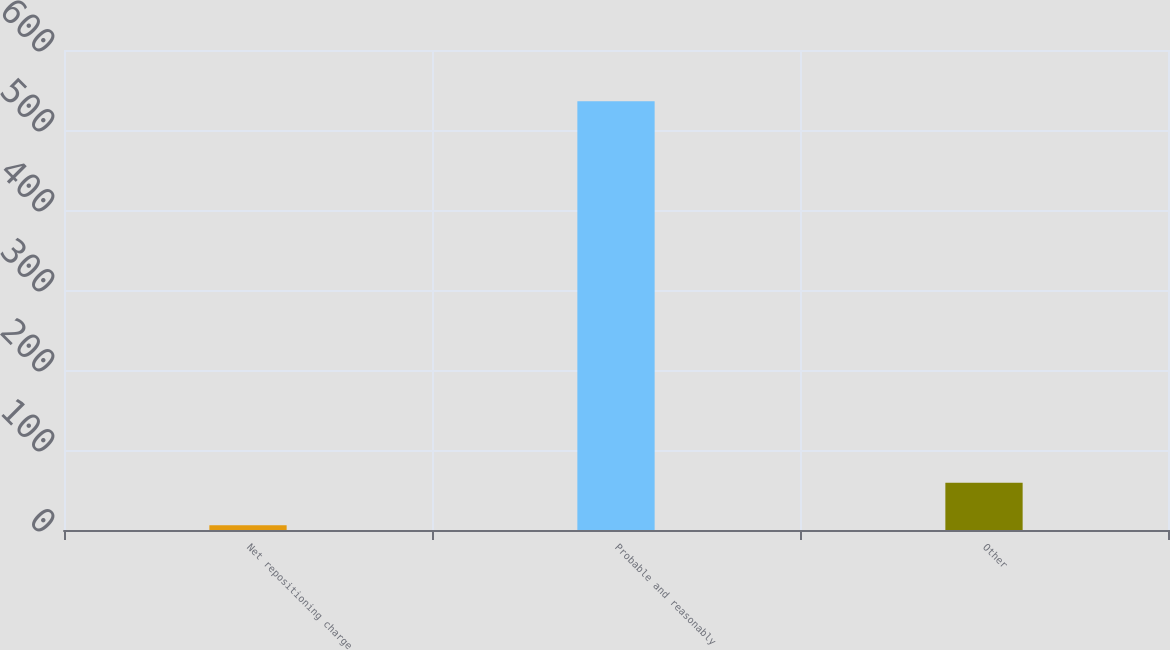<chart> <loc_0><loc_0><loc_500><loc_500><bar_chart><fcel>Net repositioning charge<fcel>Probable and reasonably<fcel>Other<nl><fcel>6<fcel>536<fcel>59<nl></chart> 